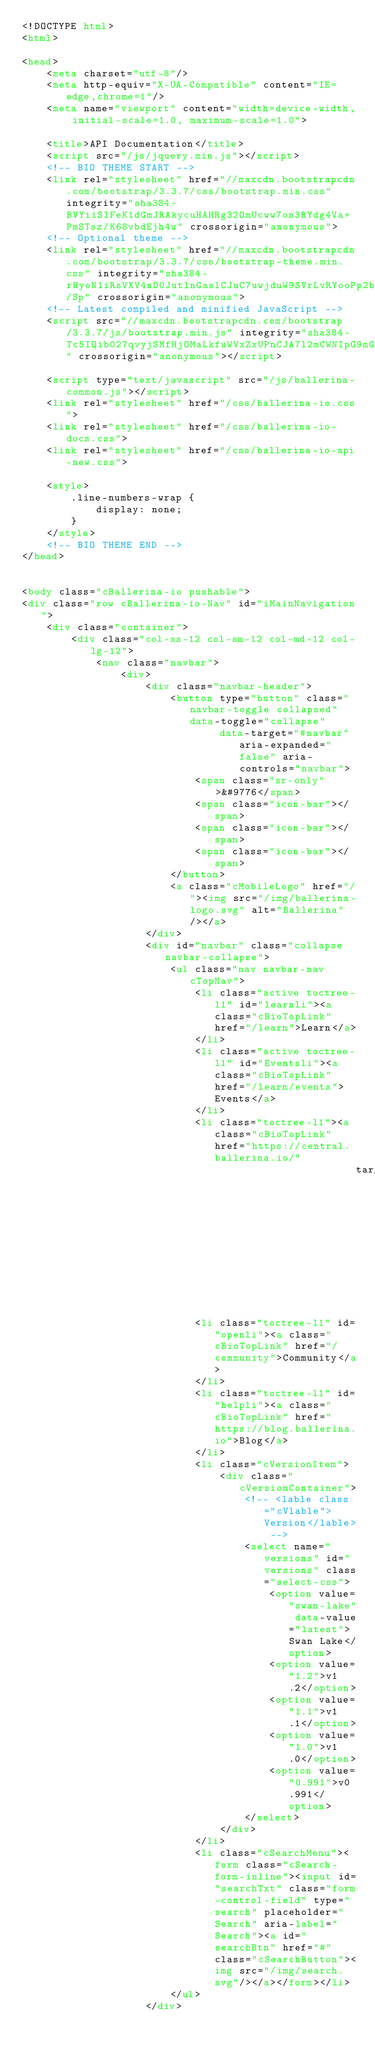Convert code to text. <code><loc_0><loc_0><loc_500><loc_500><_HTML_><!DOCTYPE html>
<html>

<head>
    <meta charset="utf-8"/>
    <meta http-equiv="X-UA-Compatible" content="IE=edge,chrome=1"/>
    <meta name="viewport" content="width=device-width, initial-scale=1.0, maximum-scale=1.0">

    <title>API Documentation</title>
    <script src="/js/jquery.min.js"></script>
    <!-- BIO THEME START -->
    <link rel="stylesheet" href="//maxcdn.bootstrapcdn.com/bootstrap/3.3.7/css/bootstrap.min.css" integrity="sha384-BVYiiSIFeK1dGmJRAkycuHAHRg32OmUcww7on3RYdg4Va+PmSTsz/K68vbdEjh4u" crossorigin="anonymous">
    <!-- Optional theme -->
    <link rel="stylesheet" href="//maxcdn.bootstrapcdn.com/bootstrap/3.3.7/css/bootstrap-theme.min.css" integrity="sha384-rHyoN1iRsVXV4nD0JutlnGaslCJuC7uwjduW9SVrLvRYooPp2bWYgmgJQIXwl/Sp" crossorigin="anonymous">
    <!-- Latest compiled and minified JavaScript -->
    <script src="//maxcdn.bootstrapcdn.com/bootstrap/3.3.7/js/bootstrap.min.js" integrity="sha384-Tc5IQib027qvyjSMfHjOMaLkfuWVxZxUPnCJA7l2mCWNIpG9mGCD8wGNIcPD7Txa" crossorigin="anonymous"></script>

    <script type="text/javascript" src="/js/ballerina-common.js"></script>
    <link rel="stylesheet" href="/css/ballerina-io.css">
    <link rel="stylesheet" href="/css/ballerina-io-docs.css">
    <link rel="stylesheet" href="/css/ballerina-io-api-new.css">

    <style>
        .line-numbers-wrap {
            display: none;
        }
    </style>
    <!-- BIO THEME END -->
</head>


<body class="cBallerina-io pushable">
<div class="row cBallerina-io-Nav" id="iMainNavigation">
    <div class="container">
        <div class="col-xs-12 col-sm-12 col-md-12 col-lg-12">
            <nav class="navbar">
                <div>
                    <div class="navbar-header">
                        <button type="button" class="navbar-toggle collapsed" data-toggle="collapse"
                                data-target="#navbar" aria-expanded="false" aria-controls="navbar">
                            <span class="sr-only">&#9776</span>
                            <span class="icon-bar"></span>
                            <span class="icon-bar"></span>
                            <span class="icon-bar"></span>
                        </button>
                        <a class="cMobileLogo" href="/"><img src="/img/ballerina-logo.svg" alt="Ballerina"/></a>
                    </div>
                    <div id="navbar" class="collapse navbar-collapse">
                        <ul class="nav navbar-nav cTopNav">
                            <li class="active toctree-l1" id="learnli"><a class="cBioTopLink" href="/learn">Learn</a>
                            </li>
                            <li class="active toctree-l1" id="Eventsli"><a class="cBioTopLink" href="/learn/events">Events</a>
                            </li>
                            <li class="toctree-l1"><a class="cBioTopLink" href="https://central.ballerina.io/"
                                                      target="_blank">Central</a></li>
                            <li class="toctree-l1" id="openli"><a class="cBioTopLink" href="/community">Community</a>
                            </li>
                            <li class="toctree-l1" id="helpli"><a class="cBioTopLink" href="https://blog.ballerina.io">Blog</a>
                            </li>
                            <li class="cVersionItem">
                                <div class="cVersionContainer">
                                    <!-- <lable class="cVlable">Version</lable> -->
                                    <select name="versions" id="versions" class="select-css">
                                        <option value="swan-lake" data-value="latest">Swan Lake</option>
                                        <option value="1.2">v1.2</option>
                                        <option value="1.1">v1.1</option>
                                        <option value="1.0">v1.0</option>
                                        <option value="0.991">v0.991</option>
                                    </select>
                                </div>
                            </li>
                            <li class="cSearchMenu"><form class="cSearch-form-inline"><input id="searchTxt" class="form-control-field" type="search" placeholder="Search" aria-label="Search"><a id="searchBtn" href="#" class="cSearchButton"><img src="/img/search.svg"/></a></form></li>
                        </ul>
                    </div></code> 